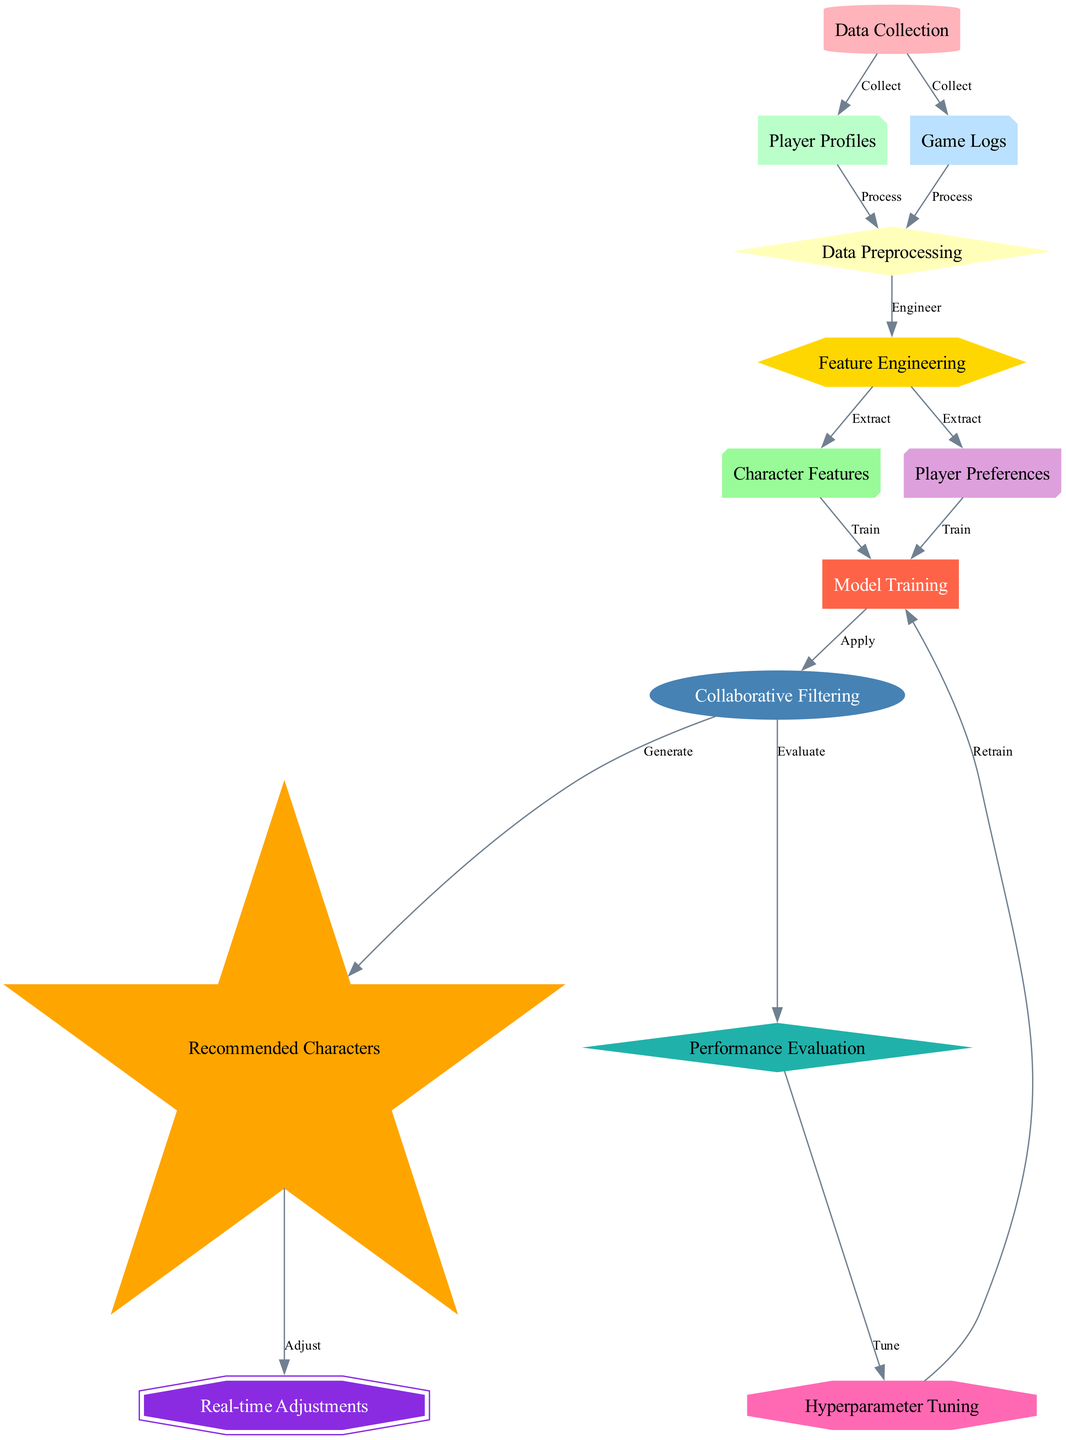What is the first step in the recommendation system? The first step, according to the diagram, is "Data Collection," which includes collecting player profiles and game logs.
Answer: Data Collection How many nodes are in the diagram? By counting the unique identifiers for each node, it can be seen that there are a total of 12 nodes present in the diagram.
Answer: 12 What is the relationship between "Data Preprocessing" and "Feature Engineering"? "Data Preprocessing" leads into "Feature Engineering" with an action of "Engineer" indicating that features are created from the processed data.
Answer: Engineer Which node generates the recommended characters? The node "Collaborative Filtering" generates the recommended characters as indicated by the edge leading to "Recommended Characters" with the label "Generate."
Answer: Recommended Characters What are the last two steps in the flow? The last two steps in the flow, according to the diagram, are "Recommended Characters" followed by "Real-time Adjustments."
Answer: Real-time Adjustments What process follows "Performance Evaluation"? After "Performance Evaluation," the process continues with "Hyperparameter Tuning," indicating that adjustments to model parameters are made based on evaluation metrics.
Answer: Hyperparameter Tuning What is the action taken from "Feature Engineering" to "Character Features"? The action taken is "Extract," which signifies that character features are derived from the engineered data.
Answer: Extract Which two elements contribute to "Model Training"? Both "Character Features" and "Player Preferences" contribute to "Model Training," as they feed into it for building the model.
Answer: Character Features and Player Preferences How is "Hyperparameter Tuning" related to "Model Training"? The relationship is a feedback loop; after "Hyperparameter Tuning," the process goes back to "Model Training" with the label "Retrain" indicating re-training the model with the tuned parameters.
Answer: Retrain 